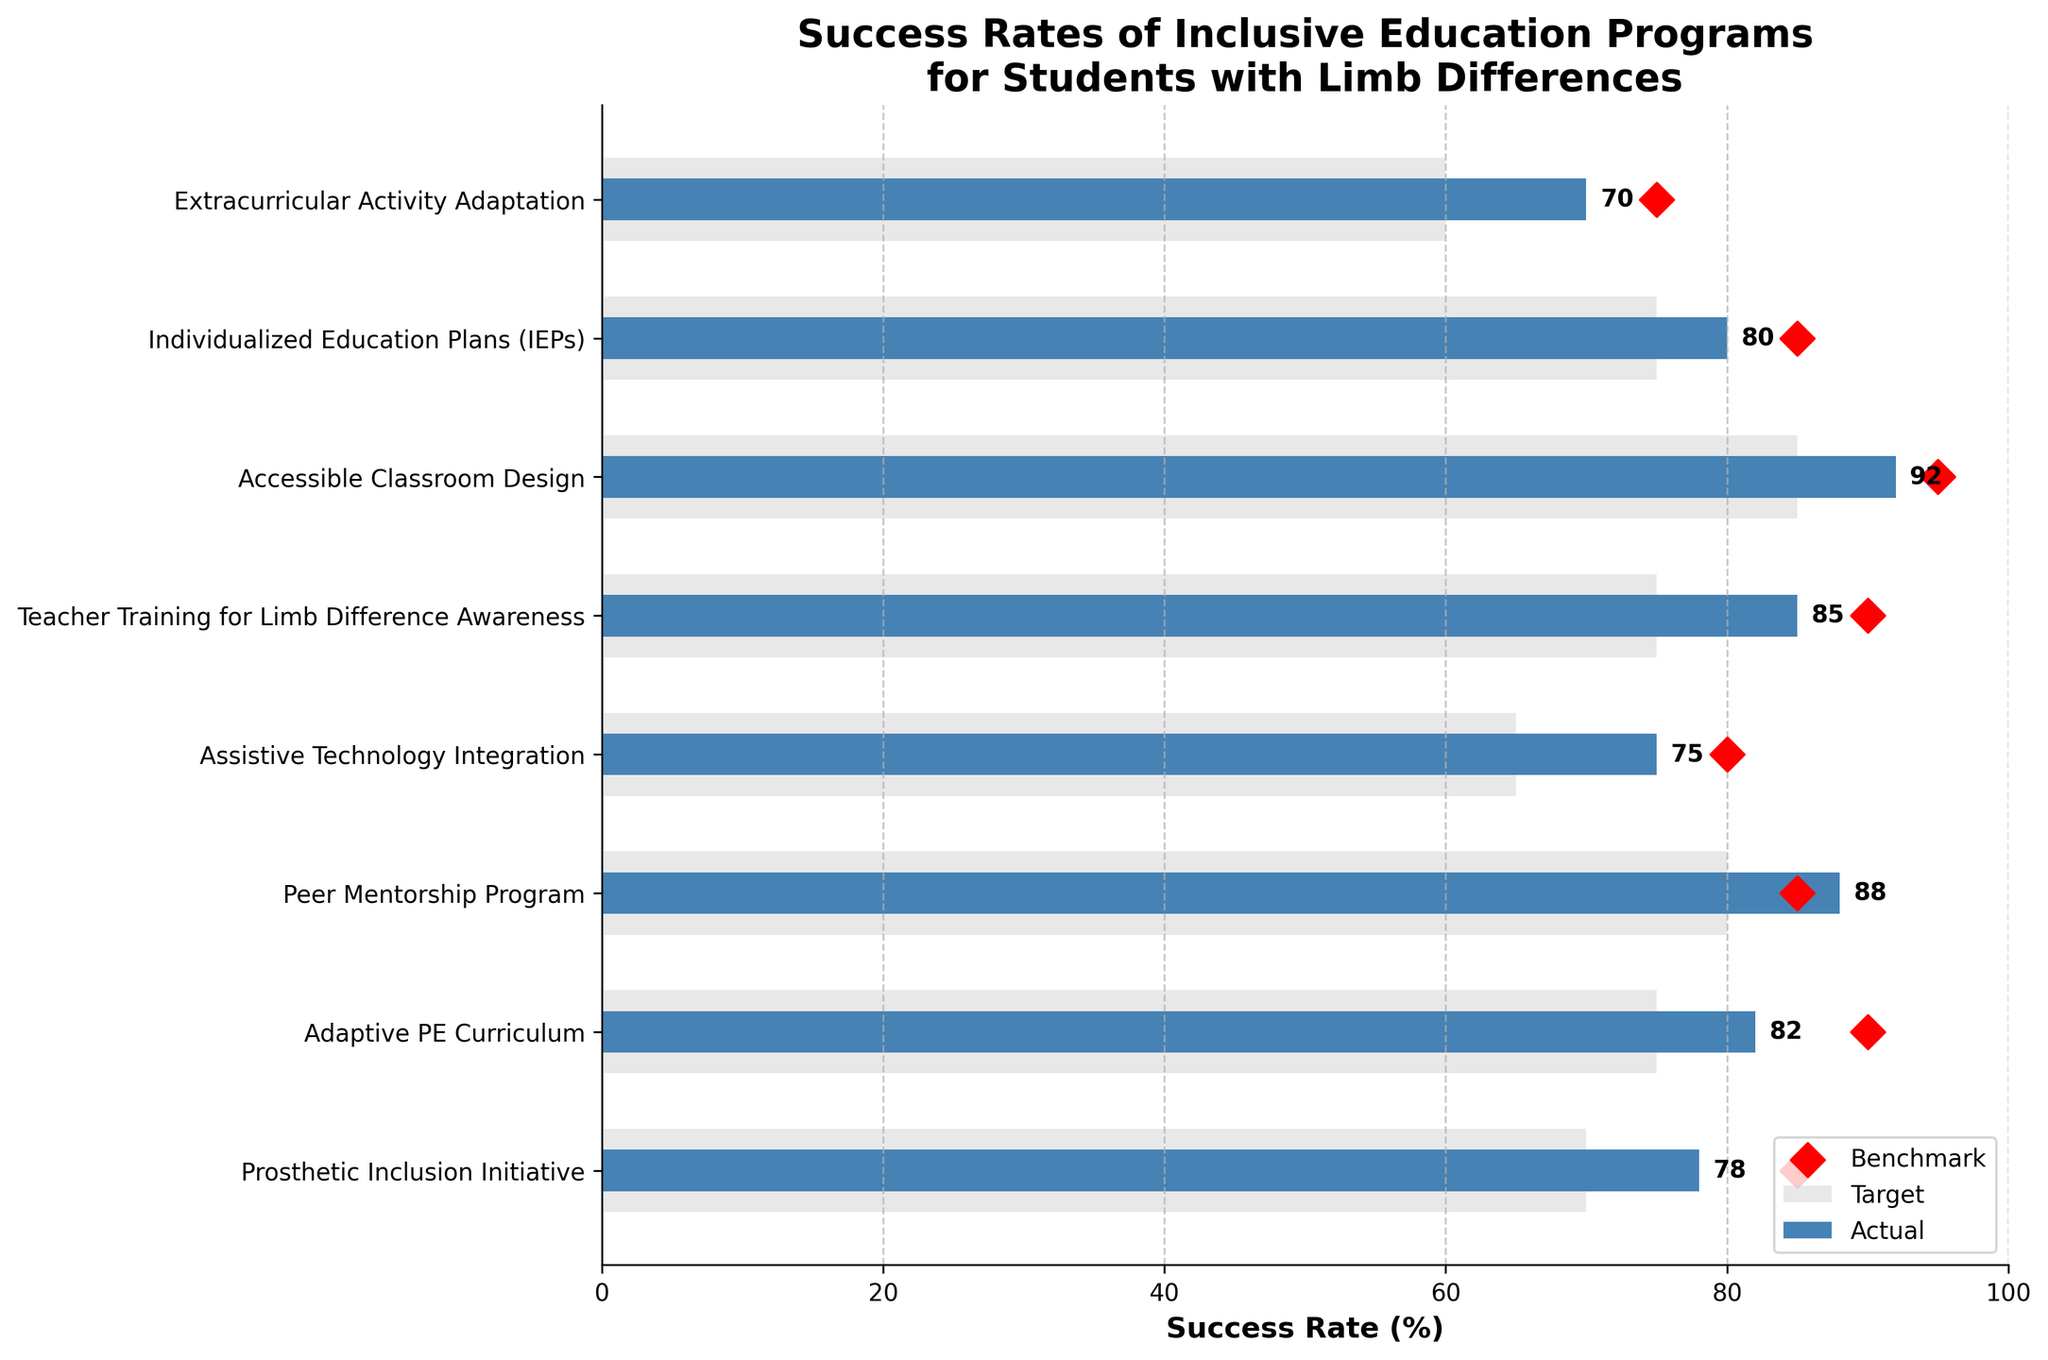How many programs have their actual success rate outperform their benchmark? First, identify the "Actual" success rates, then compare each to the corresponding "Benchmark". If actual > benchmark, count such instances: "Prosthetic Inclusion Initiative", "Adaptive PE Curriculum", "Peer Mentorship Program", "Assistive Technology Integration", "Teacher Training for Limb Difference Awareness", "Accessible Classroom Design", and "Individualized Education Plans (IEPs)"
Answer: 7 programs Which program has the highest actual success rate? Look at the bar heights that represent "Actual" success rates and find the maximum: "Accessible Classroom Design" at 92
Answer: Accessible Classroom Design List the programs where the targets were not met, meaning the actual success rate is less than the target. Review the data: Compare "Actual" to "Target". Programs not meeting targets are: "Prosthetic Inclusion Initiative", "Adaptive PE Curriculum", "Assistive Technology Integration", "Teacher Training for Limb Difference Awareness", "Individualized Education Plans (IEPs)", and "Extracurricular Activity Adaptation"
Answer: 6 programs What is the average target success rate across all programs? Sum all target success rates and divide by the number of programs: (85 + 90 + 85 + 80 + 90 + 95 + 85 + 75) / 8 = 85.625
Answer: 85.625% Which program exhibits the largest gap between its actual success rate and the benchmark? Calculate the difference (Actual - Benchmark) for each program and find the maximum: "Accessible Classroom Design" with (92 - 85 = 7)
Answer: Accessible Classroom Design How many programs have their actual success rate within 5% of their target? Identify and count programs with absolute difference within 5%: "Peer Mentorship Program" (88 - 85 = 3), and "Extracurricular Activity Adaptation" (70 - 75 = 5)
Answer: 2 programs What is the sum of the actual success rates for all programs? Add all the actual success rates: 78 + 82 + 88 + 75 + 85 + 92 + 80 + 70 = 650
Answer: 650 In which programs does the actual success rate surpass both the benchmark and the target? Actual > Benchmark and Actual > Target: The only program is "Peer Mentorship Program" (88 > 80 and 88 > 85)
Answer: Peer Mentorship Program Which programs have their benchmark success rate higher than 75%? List programs where Benchmark > 75: "Prosthetic Inclusion Initiative", "Adaptive PE Curriculum", "Peer Mentorship Program", "Teacher Training for Limb Difference Awareness", "Accessible Classroom Design", and "Individualized Education Plans (IEPs)"
Answer: 6 programs 